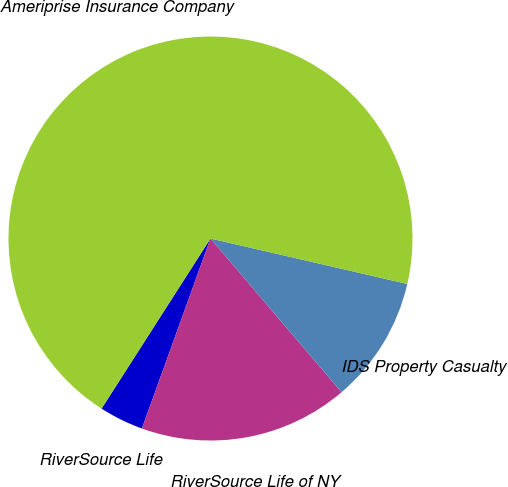Convert chart to OTSL. <chart><loc_0><loc_0><loc_500><loc_500><pie_chart><fcel>RiverSource Life<fcel>RiverSource Life of NY<fcel>IDS Property Casualty<fcel>Ameriprise Insurance Company<nl><fcel>3.55%<fcel>16.75%<fcel>10.15%<fcel>69.54%<nl></chart> 